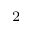<formula> <loc_0><loc_0><loc_500><loc_500>^ { 2 }</formula> 